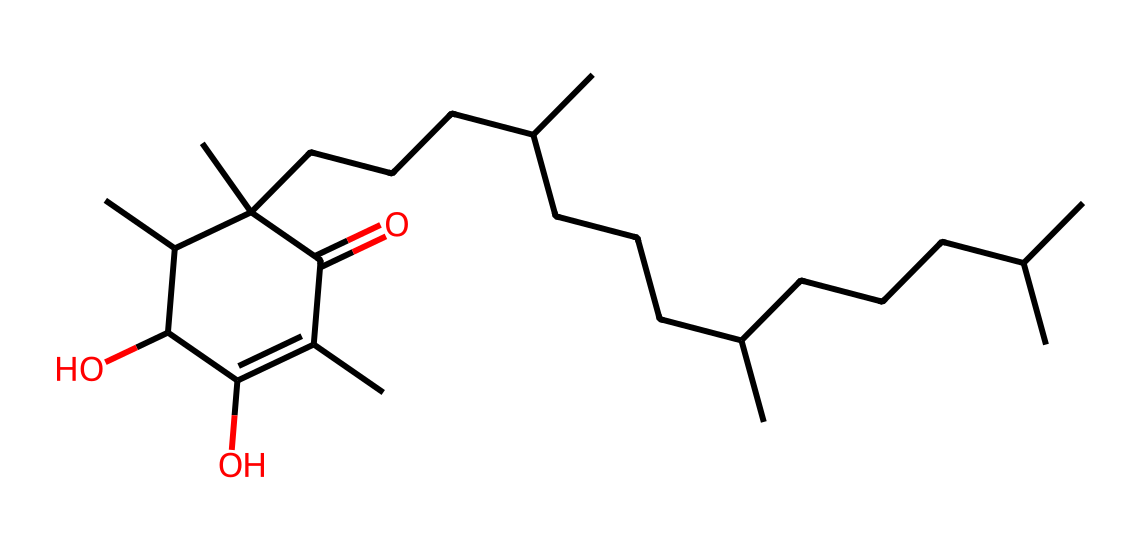What is the primary functional group in this vitamin E molecule? The molecule contains hydroxyl groups (-OH) attached to the carbon chain, which are characteristic of alcohols. These hydroxyl groups contribute to the molecule's antioxidant properties.
Answer: hydroxyl How many carbon atoms are present in the structure? By counting the carbon atoms represented in the SMILES notation, we can determine the total number. The structure shows a total of 21 carbon atoms.
Answer: 21 What type of compound is this vitamin E considered? Vitamin E is classified as a tocopherol, a type of fat-soluble vitamin, based on its structure which includes aromatic rings and long hydrocarbon tails.
Answer: tocopherol Which feature in the structure contributes to its antioxidant capacity? The presence of the hydroxyl (-OH) groups allows for the donation of hydrogen atoms, which helps to neutralize free radicals, thereby providing antioxidant benefits.
Answer: hydroxyl groups How many oxygen atoms are found in the chemical structure of this vitamin E? By analyzing the SMILES representation, the structure indicates the presence of 2 oxygen atoms connected to the carbon backbone through hydroxyl and carbonyl functionalities.
Answer: 2 What is the effect of the long carbon chain in this vitamin E on its solubility? The long carbon chain makes vitamin E hydrophobic, affecting its solubility in fats but limiting its solubility in water, which is typical for fat-soluble vitamins.
Answer: hydrophobic What role does this vitamin E play in health, particularly when included in snacks? Vitamin E functions primarily as an antioxidant, helping to protect cell membranes from oxidative damage when consumed in nuts and seeds as healthy snacks.
Answer: antioxidant 